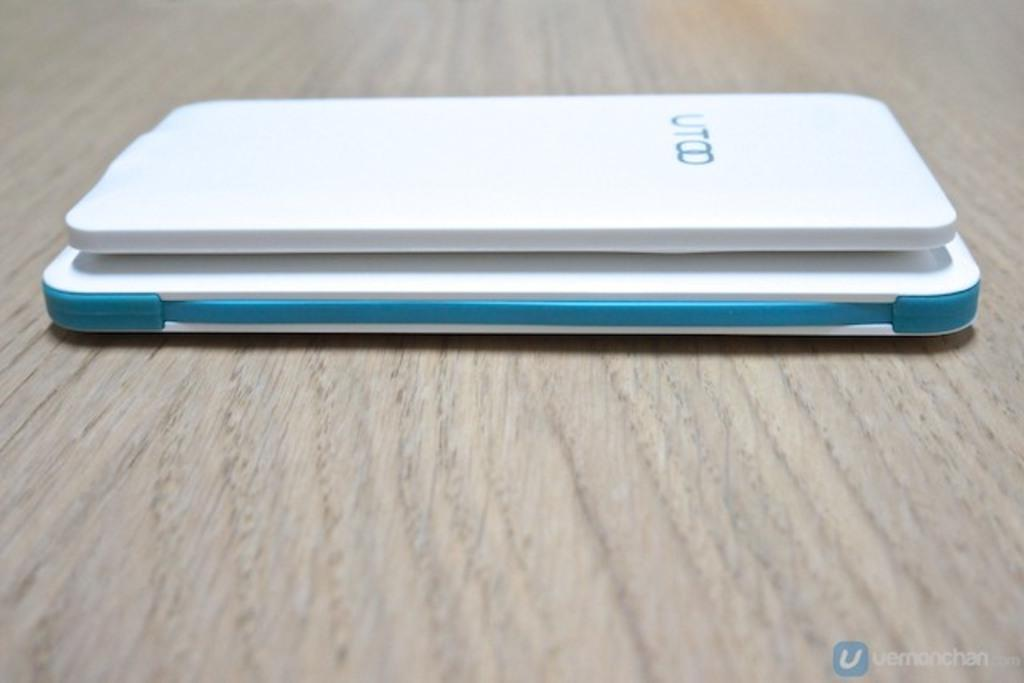<image>
Summarize the visual content of the image. A UTOO ITEM TRIMMED IN BLUE AND WHITE IN COLOR ON A TABLE. 